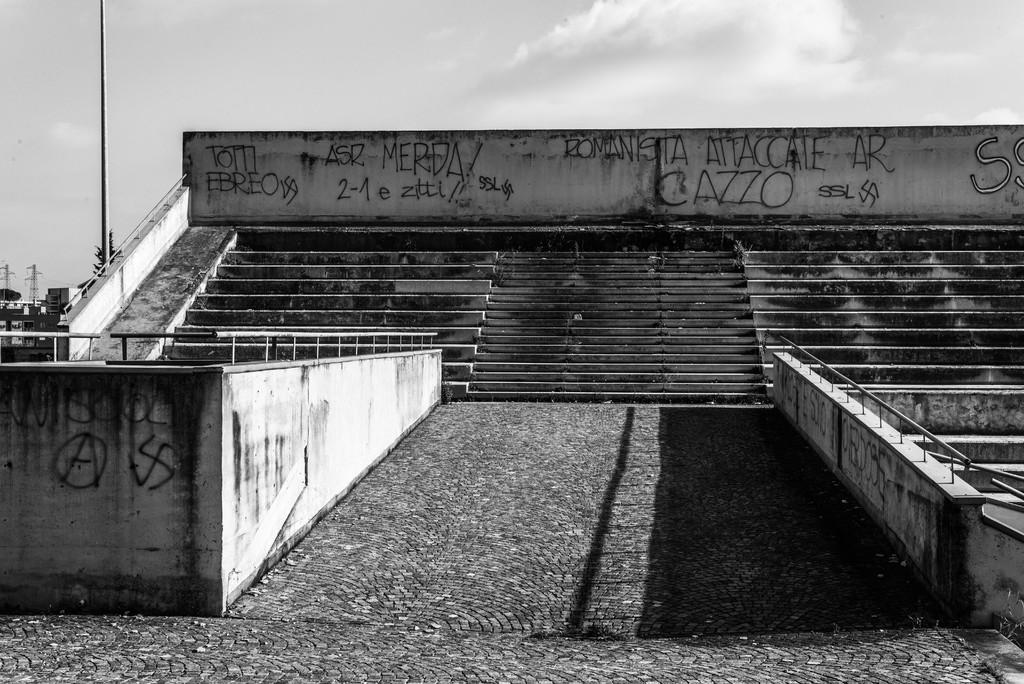What is the color scheme of the image? The image is black and white. What architectural feature can be seen in the image? There are steps in the image. What is written on the walls in the image? Texts are written on the walls in the image. What safety feature is present in the image? Railings are present in the image. What is visible in the background of the image? There is a pole, a tree, towers, and other objects in the background of the image. What can be seen in the sky in the background of the image? Clouds are visible in the sky in the background of the image. What type of glove is being used to write the texts on the walls in the image? There is no glove present in the image, and the texts on the walls are not being written in the image. --- Facts: 1. There is a person sitting on a chair in the image. 2. The person is holding a book. 3. The book has a red cover. 4. There is a table next to the chair. 5. There is a lamp on the table. 6. The lamp has a green shade. Absurd Topics: parrot, ocean, bicycle Conversation: What is the person in the image doing? The person is sitting on a chair in the image. What is the person holding in the image? The person is holding a book in the image. What is the color of the book's cover? The book has a red cover. What is located next to the chair in the image? There is a table next to the chair in the image. What is on the table in the image? There is a lamp on the table in the image. What is the color of the lamp's shade? The lamp has a green shade. Reasoning: Let's think step by step in order to produce the conversation. We start by identifying the main subject in the image, which is the person sitting on a chair. Then, we describe what the person is holding, which is a book with a red cover. Next, we mention the presence of a table next to the chair and a lamp on the table. Finally, we describe the lamp's shade, which is green. Absurd Question/Answer: Can you see a parrot swimming in the ocean in the image? There is no parrot or ocean present in the image. --- Facts: 1. There is a person standing on a bridge in the image. 2. The person is holding a camera. 3. The bridge is made of wood. 4. There is a river below the bridge. 5. The river has a strong current. 6. There are trees 